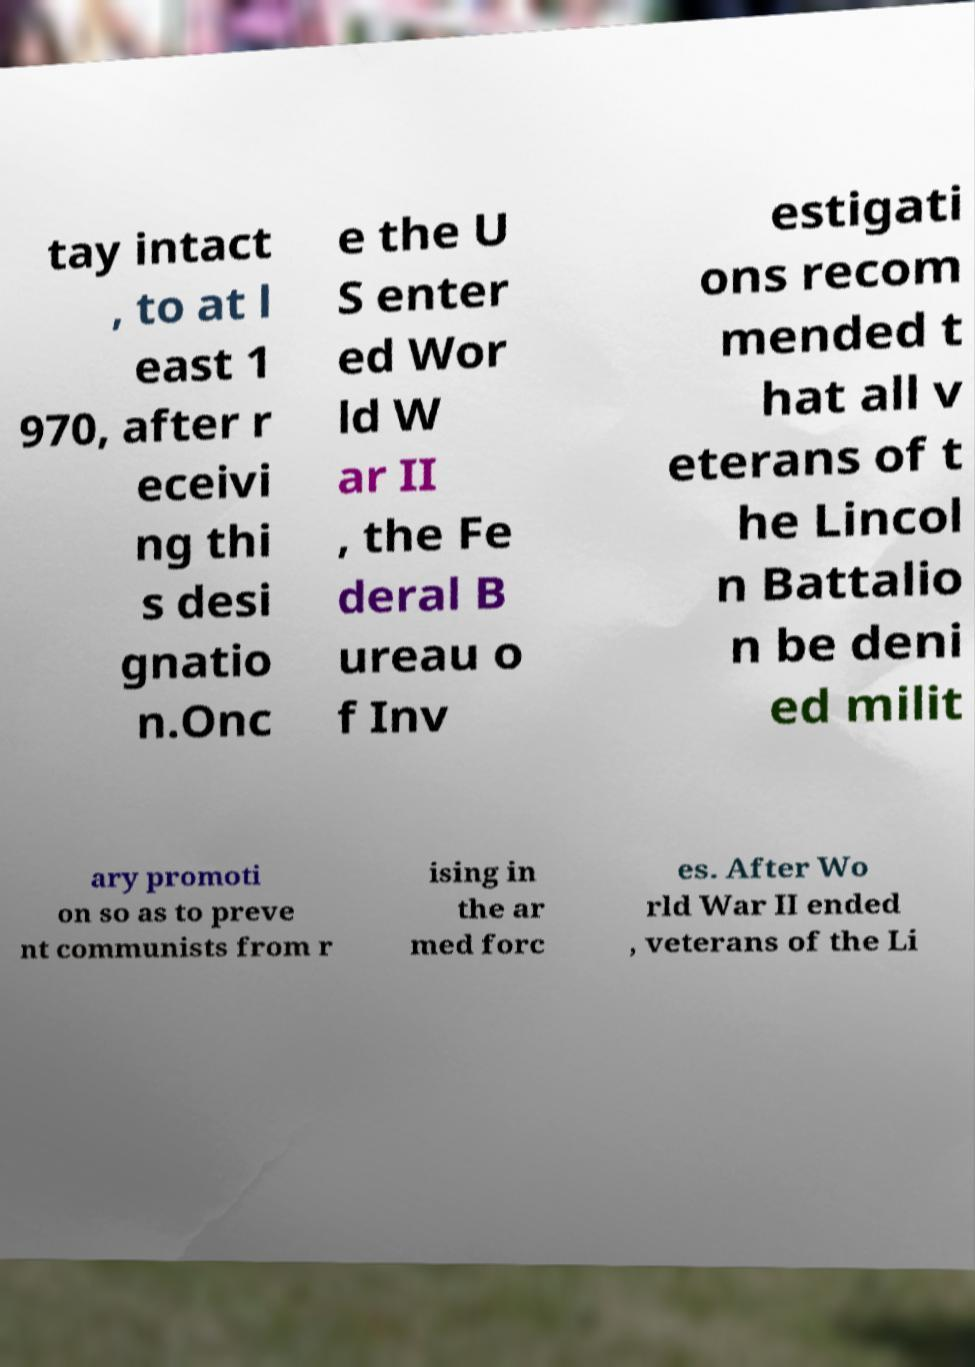For documentation purposes, I need the text within this image transcribed. Could you provide that? tay intact , to at l east 1 970, after r eceivi ng thi s desi gnatio n.Onc e the U S enter ed Wor ld W ar II , the Fe deral B ureau o f Inv estigati ons recom mended t hat all v eterans of t he Lincol n Battalio n be deni ed milit ary promoti on so as to preve nt communists from r ising in the ar med forc es. After Wo rld War II ended , veterans of the Li 